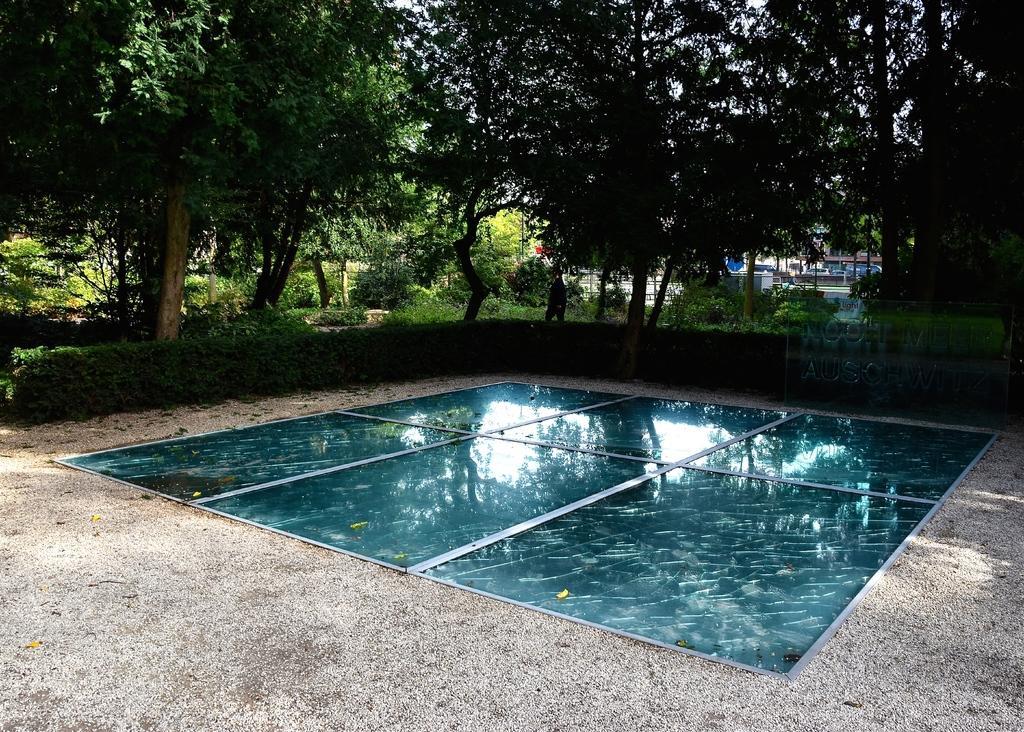In one or two sentences, can you explain what this image depicts? This picture is clicked outside. In the center there is an object placed on the ground. In the background we can see the plants, shrubs, trees and some houses. 